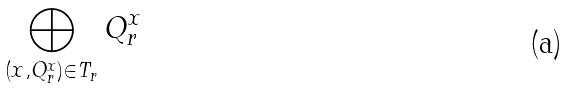Convert formula to latex. <formula><loc_0><loc_0><loc_500><loc_500>\bigoplus _ { ( x , Q _ { r } ^ { x } ) \in T _ { r } } Q _ { r } ^ { x }</formula> 